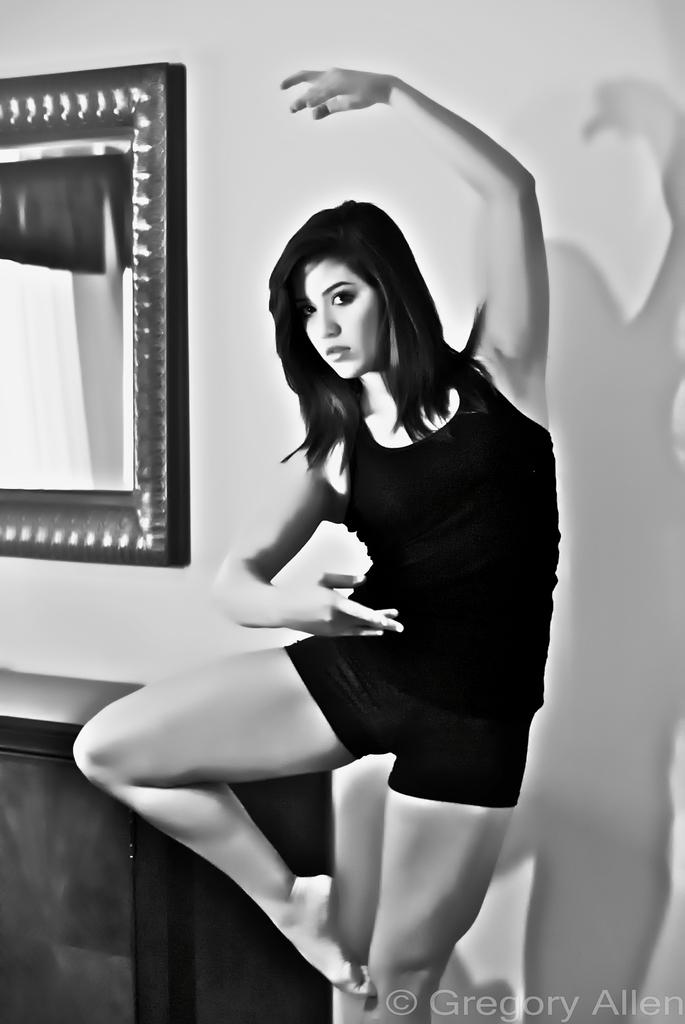Who is the main subject in the image? There is a woman in the image. What is behind the woman in the image? There is a wall behind the woman. What can be seen on the left side of the image? There is a mirror and a table on the left side of the image. Where is the text located in the image? There is some text in the bottom right of the image. What type of quartz is used to adjust the mirror in the image? There is no quartz present in the image, nor is there any adjustment being made to the mirror. 